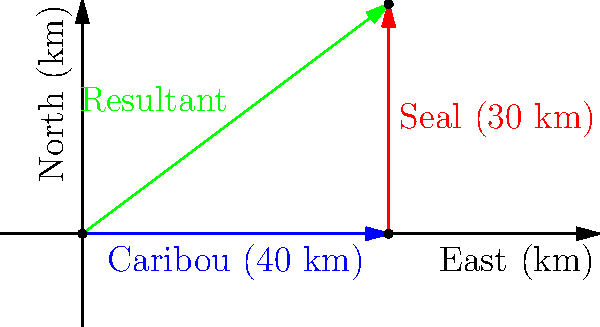As climate change affects the Arctic, you've noticed changes in the migration patterns of caribou and seals, two important food sources for your community. The caribou have shifted 40 km east, while the seals have moved 30 km north from their usual locations. What is the straight-line distance and direction from the original location to the new area where both species can now be found? To solve this problem, we need to use vector addition:

1) Let's define our vectors:
   - Caribou movement: $\vec{a} = 40\text{ km east} = (40, 0)$
   - Seal movement: $\vec{b} = 30\text{ km north} = (0, 30)$

2) The resultant vector $\vec{r}$ is the sum of these vectors:
   $\vec{r} = \vec{a} + \vec{b} = (40, 0) + (0, 30) = (40, 30)$

3) To find the magnitude (distance) of this resultant vector:
   $|\vec{r}| = \sqrt{40^2 + 30^2} = \sqrt{1600 + 900} = \sqrt{2500} = 50\text{ km}$

4) To find the direction, we calculate the angle $\theta$ from the east:
   $\theta = \tan^{-1}(\frac{30}{40}) \approx 36.87°$

Therefore, the new location is 50 km away from the original location, at an angle of approximately 36.87° north of east.
Answer: 50 km, 36.87° north of east 